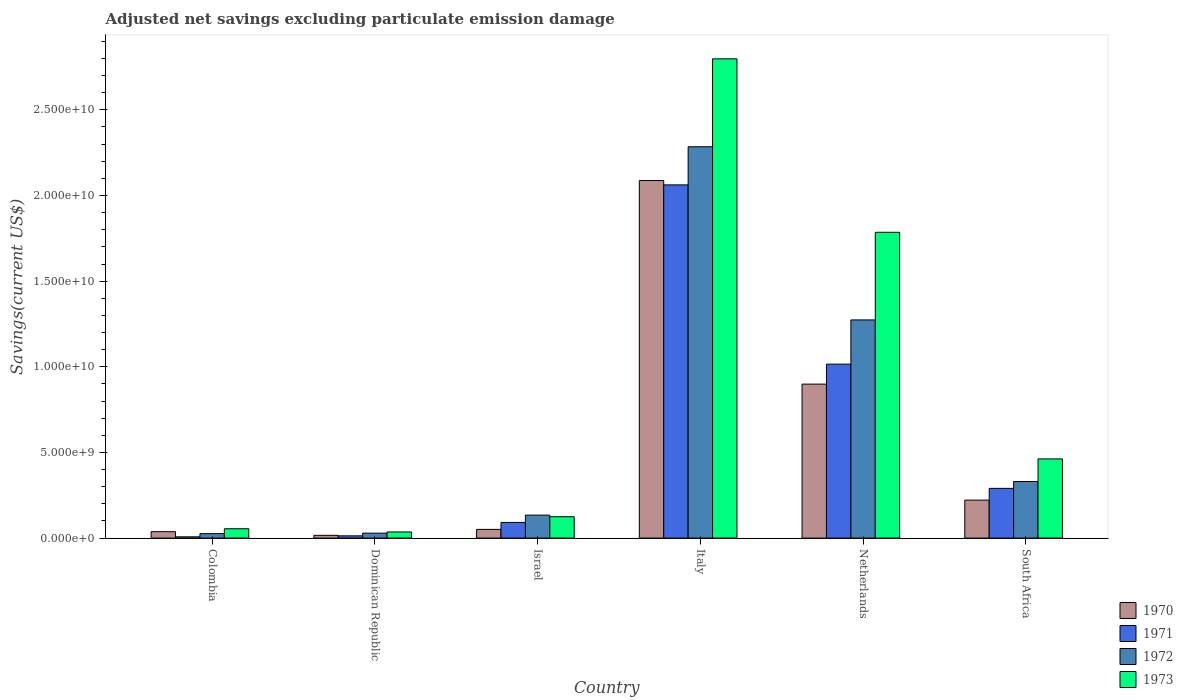How many groups of bars are there?
Keep it short and to the point. 6. Are the number of bars on each tick of the X-axis equal?
Your response must be concise. Yes. What is the label of the 2nd group of bars from the left?
Give a very brief answer. Dominican Republic. What is the adjusted net savings in 1972 in Dominican Republic?
Your answer should be very brief. 2.89e+08. Across all countries, what is the maximum adjusted net savings in 1973?
Offer a very short reply. 2.80e+1. Across all countries, what is the minimum adjusted net savings in 1973?
Give a very brief answer. 3.58e+08. In which country was the adjusted net savings in 1970 maximum?
Your answer should be very brief. Italy. In which country was the adjusted net savings in 1973 minimum?
Ensure brevity in your answer.  Dominican Republic. What is the total adjusted net savings in 1970 in the graph?
Make the answer very short. 3.31e+1. What is the difference between the adjusted net savings in 1973 in Dominican Republic and that in South Africa?
Ensure brevity in your answer.  -4.26e+09. What is the difference between the adjusted net savings in 1971 in Israel and the adjusted net savings in 1970 in Dominican Republic?
Offer a very short reply. 7.53e+08. What is the average adjusted net savings in 1971 per country?
Provide a succinct answer. 5.80e+09. What is the difference between the adjusted net savings of/in 1971 and adjusted net savings of/in 1970 in Dominican Republic?
Make the answer very short. -2.96e+07. What is the ratio of the adjusted net savings in 1971 in Colombia to that in Israel?
Keep it short and to the point. 0.08. Is the adjusted net savings in 1972 in Colombia less than that in Netherlands?
Ensure brevity in your answer.  Yes. What is the difference between the highest and the second highest adjusted net savings in 1970?
Make the answer very short. 1.19e+1. What is the difference between the highest and the lowest adjusted net savings in 1973?
Make the answer very short. 2.76e+1. In how many countries, is the adjusted net savings in 1972 greater than the average adjusted net savings in 1972 taken over all countries?
Offer a terse response. 2. What does the 1st bar from the right in Dominican Republic represents?
Offer a very short reply. 1973. Is it the case that in every country, the sum of the adjusted net savings in 1972 and adjusted net savings in 1973 is greater than the adjusted net savings in 1970?
Offer a very short reply. Yes. How many bars are there?
Keep it short and to the point. 24. How many countries are there in the graph?
Provide a succinct answer. 6. What is the difference between two consecutive major ticks on the Y-axis?
Your answer should be very brief. 5.00e+09. Does the graph contain any zero values?
Offer a terse response. No. Does the graph contain grids?
Give a very brief answer. No. How many legend labels are there?
Offer a very short reply. 4. How are the legend labels stacked?
Provide a succinct answer. Vertical. What is the title of the graph?
Give a very brief answer. Adjusted net savings excluding particulate emission damage. Does "1961" appear as one of the legend labels in the graph?
Your answer should be compact. No. What is the label or title of the X-axis?
Give a very brief answer. Country. What is the label or title of the Y-axis?
Provide a succinct answer. Savings(current US$). What is the Savings(current US$) of 1970 in Colombia?
Keep it short and to the point. 3.74e+08. What is the Savings(current US$) in 1971 in Colombia?
Provide a succinct answer. 7.46e+07. What is the Savings(current US$) of 1972 in Colombia?
Offer a very short reply. 2.60e+08. What is the Savings(current US$) in 1973 in Colombia?
Ensure brevity in your answer.  5.45e+08. What is the Savings(current US$) of 1970 in Dominican Republic?
Give a very brief answer. 1.61e+08. What is the Savings(current US$) in 1971 in Dominican Republic?
Keep it short and to the point. 1.32e+08. What is the Savings(current US$) of 1972 in Dominican Republic?
Make the answer very short. 2.89e+08. What is the Savings(current US$) in 1973 in Dominican Republic?
Your answer should be very brief. 3.58e+08. What is the Savings(current US$) of 1970 in Israel?
Provide a short and direct response. 5.08e+08. What is the Savings(current US$) of 1971 in Israel?
Your answer should be compact. 9.14e+08. What is the Savings(current US$) in 1972 in Israel?
Your answer should be compact. 1.34e+09. What is the Savings(current US$) in 1973 in Israel?
Offer a terse response. 1.25e+09. What is the Savings(current US$) in 1970 in Italy?
Provide a short and direct response. 2.09e+1. What is the Savings(current US$) of 1971 in Italy?
Offer a very short reply. 2.06e+1. What is the Savings(current US$) in 1972 in Italy?
Provide a succinct answer. 2.28e+1. What is the Savings(current US$) in 1973 in Italy?
Your answer should be compact. 2.80e+1. What is the Savings(current US$) in 1970 in Netherlands?
Ensure brevity in your answer.  8.99e+09. What is the Savings(current US$) in 1971 in Netherlands?
Make the answer very short. 1.02e+1. What is the Savings(current US$) in 1972 in Netherlands?
Keep it short and to the point. 1.27e+1. What is the Savings(current US$) of 1973 in Netherlands?
Make the answer very short. 1.79e+1. What is the Savings(current US$) in 1970 in South Africa?
Make the answer very short. 2.22e+09. What is the Savings(current US$) in 1971 in South Africa?
Offer a very short reply. 2.90e+09. What is the Savings(current US$) of 1972 in South Africa?
Ensure brevity in your answer.  3.30e+09. What is the Savings(current US$) of 1973 in South Africa?
Your response must be concise. 4.62e+09. Across all countries, what is the maximum Savings(current US$) of 1970?
Give a very brief answer. 2.09e+1. Across all countries, what is the maximum Savings(current US$) in 1971?
Your answer should be compact. 2.06e+1. Across all countries, what is the maximum Savings(current US$) of 1972?
Your answer should be very brief. 2.28e+1. Across all countries, what is the maximum Savings(current US$) in 1973?
Provide a succinct answer. 2.80e+1. Across all countries, what is the minimum Savings(current US$) in 1970?
Provide a short and direct response. 1.61e+08. Across all countries, what is the minimum Savings(current US$) of 1971?
Your answer should be compact. 7.46e+07. Across all countries, what is the minimum Savings(current US$) in 1972?
Your response must be concise. 2.60e+08. Across all countries, what is the minimum Savings(current US$) in 1973?
Keep it short and to the point. 3.58e+08. What is the total Savings(current US$) of 1970 in the graph?
Your answer should be very brief. 3.31e+1. What is the total Savings(current US$) of 1971 in the graph?
Provide a succinct answer. 3.48e+1. What is the total Savings(current US$) in 1972 in the graph?
Your response must be concise. 4.08e+1. What is the total Savings(current US$) of 1973 in the graph?
Keep it short and to the point. 5.26e+1. What is the difference between the Savings(current US$) of 1970 in Colombia and that in Dominican Republic?
Give a very brief answer. 2.13e+08. What is the difference between the Savings(current US$) in 1971 in Colombia and that in Dominican Republic?
Offer a very short reply. -5.69e+07. What is the difference between the Savings(current US$) of 1972 in Colombia and that in Dominican Republic?
Make the answer very short. -2.84e+07. What is the difference between the Savings(current US$) of 1973 in Colombia and that in Dominican Republic?
Your response must be concise. 1.87e+08. What is the difference between the Savings(current US$) of 1970 in Colombia and that in Israel?
Your answer should be compact. -1.34e+08. What is the difference between the Savings(current US$) in 1971 in Colombia and that in Israel?
Give a very brief answer. -8.40e+08. What is the difference between the Savings(current US$) in 1972 in Colombia and that in Israel?
Your answer should be compact. -1.08e+09. What is the difference between the Savings(current US$) in 1973 in Colombia and that in Israel?
Make the answer very short. -7.02e+08. What is the difference between the Savings(current US$) of 1970 in Colombia and that in Italy?
Provide a succinct answer. -2.05e+1. What is the difference between the Savings(current US$) in 1971 in Colombia and that in Italy?
Offer a very short reply. -2.05e+1. What is the difference between the Savings(current US$) of 1972 in Colombia and that in Italy?
Provide a short and direct response. -2.26e+1. What is the difference between the Savings(current US$) of 1973 in Colombia and that in Italy?
Offer a very short reply. -2.74e+1. What is the difference between the Savings(current US$) of 1970 in Colombia and that in Netherlands?
Provide a succinct answer. -8.61e+09. What is the difference between the Savings(current US$) of 1971 in Colombia and that in Netherlands?
Ensure brevity in your answer.  -1.01e+1. What is the difference between the Savings(current US$) in 1972 in Colombia and that in Netherlands?
Provide a succinct answer. -1.25e+1. What is the difference between the Savings(current US$) in 1973 in Colombia and that in Netherlands?
Ensure brevity in your answer.  -1.73e+1. What is the difference between the Savings(current US$) of 1970 in Colombia and that in South Africa?
Keep it short and to the point. -1.84e+09. What is the difference between the Savings(current US$) in 1971 in Colombia and that in South Africa?
Provide a succinct answer. -2.83e+09. What is the difference between the Savings(current US$) in 1972 in Colombia and that in South Africa?
Ensure brevity in your answer.  -3.04e+09. What is the difference between the Savings(current US$) in 1973 in Colombia and that in South Africa?
Your answer should be very brief. -4.08e+09. What is the difference between the Savings(current US$) of 1970 in Dominican Republic and that in Israel?
Make the answer very short. -3.47e+08. What is the difference between the Savings(current US$) of 1971 in Dominican Republic and that in Israel?
Offer a very short reply. -7.83e+08. What is the difference between the Savings(current US$) of 1972 in Dominican Republic and that in Israel?
Ensure brevity in your answer.  -1.05e+09. What is the difference between the Savings(current US$) in 1973 in Dominican Republic and that in Israel?
Offer a terse response. -8.89e+08. What is the difference between the Savings(current US$) of 1970 in Dominican Republic and that in Italy?
Keep it short and to the point. -2.07e+1. What is the difference between the Savings(current US$) in 1971 in Dominican Republic and that in Italy?
Your answer should be compact. -2.05e+1. What is the difference between the Savings(current US$) in 1972 in Dominican Republic and that in Italy?
Ensure brevity in your answer.  -2.26e+1. What is the difference between the Savings(current US$) in 1973 in Dominican Republic and that in Italy?
Your answer should be compact. -2.76e+1. What is the difference between the Savings(current US$) in 1970 in Dominican Republic and that in Netherlands?
Offer a terse response. -8.83e+09. What is the difference between the Savings(current US$) in 1971 in Dominican Republic and that in Netherlands?
Provide a short and direct response. -1.00e+1. What is the difference between the Savings(current US$) in 1972 in Dominican Republic and that in Netherlands?
Your answer should be very brief. -1.24e+1. What is the difference between the Savings(current US$) of 1973 in Dominican Republic and that in Netherlands?
Provide a succinct answer. -1.75e+1. What is the difference between the Savings(current US$) of 1970 in Dominican Republic and that in South Africa?
Offer a terse response. -2.06e+09. What is the difference between the Savings(current US$) of 1971 in Dominican Republic and that in South Africa?
Make the answer very short. -2.77e+09. What is the difference between the Savings(current US$) in 1972 in Dominican Republic and that in South Africa?
Your response must be concise. -3.01e+09. What is the difference between the Savings(current US$) in 1973 in Dominican Republic and that in South Africa?
Provide a succinct answer. -4.26e+09. What is the difference between the Savings(current US$) in 1970 in Israel and that in Italy?
Ensure brevity in your answer.  -2.04e+1. What is the difference between the Savings(current US$) of 1971 in Israel and that in Italy?
Make the answer very short. -1.97e+1. What is the difference between the Savings(current US$) of 1972 in Israel and that in Italy?
Your response must be concise. -2.15e+1. What is the difference between the Savings(current US$) of 1973 in Israel and that in Italy?
Your answer should be very brief. -2.67e+1. What is the difference between the Savings(current US$) in 1970 in Israel and that in Netherlands?
Provide a succinct answer. -8.48e+09. What is the difference between the Savings(current US$) of 1971 in Israel and that in Netherlands?
Provide a succinct answer. -9.24e+09. What is the difference between the Savings(current US$) of 1972 in Israel and that in Netherlands?
Your answer should be very brief. -1.14e+1. What is the difference between the Savings(current US$) in 1973 in Israel and that in Netherlands?
Offer a very short reply. -1.66e+1. What is the difference between the Savings(current US$) in 1970 in Israel and that in South Africa?
Ensure brevity in your answer.  -1.71e+09. What is the difference between the Savings(current US$) in 1971 in Israel and that in South Africa?
Ensure brevity in your answer.  -1.99e+09. What is the difference between the Savings(current US$) of 1972 in Israel and that in South Africa?
Your response must be concise. -1.96e+09. What is the difference between the Savings(current US$) in 1973 in Israel and that in South Africa?
Make the answer very short. -3.38e+09. What is the difference between the Savings(current US$) in 1970 in Italy and that in Netherlands?
Make the answer very short. 1.19e+1. What is the difference between the Savings(current US$) of 1971 in Italy and that in Netherlands?
Provide a short and direct response. 1.05e+1. What is the difference between the Savings(current US$) in 1972 in Italy and that in Netherlands?
Keep it short and to the point. 1.01e+1. What is the difference between the Savings(current US$) of 1973 in Italy and that in Netherlands?
Offer a very short reply. 1.01e+1. What is the difference between the Savings(current US$) in 1970 in Italy and that in South Africa?
Offer a very short reply. 1.87e+1. What is the difference between the Savings(current US$) in 1971 in Italy and that in South Africa?
Your answer should be very brief. 1.77e+1. What is the difference between the Savings(current US$) of 1972 in Italy and that in South Africa?
Keep it short and to the point. 1.95e+1. What is the difference between the Savings(current US$) of 1973 in Italy and that in South Africa?
Keep it short and to the point. 2.34e+1. What is the difference between the Savings(current US$) of 1970 in Netherlands and that in South Africa?
Give a very brief answer. 6.77e+09. What is the difference between the Savings(current US$) of 1971 in Netherlands and that in South Africa?
Provide a short and direct response. 7.25e+09. What is the difference between the Savings(current US$) of 1972 in Netherlands and that in South Africa?
Make the answer very short. 9.43e+09. What is the difference between the Savings(current US$) of 1973 in Netherlands and that in South Africa?
Provide a succinct answer. 1.32e+1. What is the difference between the Savings(current US$) in 1970 in Colombia and the Savings(current US$) in 1971 in Dominican Republic?
Provide a short and direct response. 2.42e+08. What is the difference between the Savings(current US$) in 1970 in Colombia and the Savings(current US$) in 1972 in Dominican Republic?
Give a very brief answer. 8.52e+07. What is the difference between the Savings(current US$) of 1970 in Colombia and the Savings(current US$) of 1973 in Dominican Republic?
Keep it short and to the point. 1.57e+07. What is the difference between the Savings(current US$) of 1971 in Colombia and the Savings(current US$) of 1972 in Dominican Republic?
Provide a succinct answer. -2.14e+08. What is the difference between the Savings(current US$) in 1971 in Colombia and the Savings(current US$) in 1973 in Dominican Republic?
Your response must be concise. -2.84e+08. What is the difference between the Savings(current US$) in 1972 in Colombia and the Savings(current US$) in 1973 in Dominican Republic?
Provide a succinct answer. -9.79e+07. What is the difference between the Savings(current US$) in 1970 in Colombia and the Savings(current US$) in 1971 in Israel?
Provide a short and direct response. -5.40e+08. What is the difference between the Savings(current US$) of 1970 in Colombia and the Savings(current US$) of 1972 in Israel?
Ensure brevity in your answer.  -9.67e+08. What is the difference between the Savings(current US$) of 1970 in Colombia and the Savings(current US$) of 1973 in Israel?
Your response must be concise. -8.73e+08. What is the difference between the Savings(current US$) in 1971 in Colombia and the Savings(current US$) in 1972 in Israel?
Provide a succinct answer. -1.27e+09. What is the difference between the Savings(current US$) in 1971 in Colombia and the Savings(current US$) in 1973 in Israel?
Provide a succinct answer. -1.17e+09. What is the difference between the Savings(current US$) of 1972 in Colombia and the Savings(current US$) of 1973 in Israel?
Your answer should be compact. -9.87e+08. What is the difference between the Savings(current US$) in 1970 in Colombia and the Savings(current US$) in 1971 in Italy?
Provide a succinct answer. -2.02e+1. What is the difference between the Savings(current US$) of 1970 in Colombia and the Savings(current US$) of 1972 in Italy?
Offer a terse response. -2.25e+1. What is the difference between the Savings(current US$) of 1970 in Colombia and the Savings(current US$) of 1973 in Italy?
Your response must be concise. -2.76e+1. What is the difference between the Savings(current US$) in 1971 in Colombia and the Savings(current US$) in 1972 in Italy?
Make the answer very short. -2.28e+1. What is the difference between the Savings(current US$) of 1971 in Colombia and the Savings(current US$) of 1973 in Italy?
Give a very brief answer. -2.79e+1. What is the difference between the Savings(current US$) in 1972 in Colombia and the Savings(current US$) in 1973 in Italy?
Your answer should be very brief. -2.77e+1. What is the difference between the Savings(current US$) of 1970 in Colombia and the Savings(current US$) of 1971 in Netherlands?
Keep it short and to the point. -9.78e+09. What is the difference between the Savings(current US$) of 1970 in Colombia and the Savings(current US$) of 1972 in Netherlands?
Give a very brief answer. -1.24e+1. What is the difference between the Savings(current US$) of 1970 in Colombia and the Savings(current US$) of 1973 in Netherlands?
Your answer should be compact. -1.75e+1. What is the difference between the Savings(current US$) of 1971 in Colombia and the Savings(current US$) of 1972 in Netherlands?
Your response must be concise. -1.27e+1. What is the difference between the Savings(current US$) in 1971 in Colombia and the Savings(current US$) in 1973 in Netherlands?
Ensure brevity in your answer.  -1.78e+1. What is the difference between the Savings(current US$) of 1972 in Colombia and the Savings(current US$) of 1973 in Netherlands?
Make the answer very short. -1.76e+1. What is the difference between the Savings(current US$) in 1970 in Colombia and the Savings(current US$) in 1971 in South Africa?
Give a very brief answer. -2.53e+09. What is the difference between the Savings(current US$) of 1970 in Colombia and the Savings(current US$) of 1972 in South Africa?
Give a very brief answer. -2.93e+09. What is the difference between the Savings(current US$) in 1970 in Colombia and the Savings(current US$) in 1973 in South Africa?
Keep it short and to the point. -4.25e+09. What is the difference between the Savings(current US$) in 1971 in Colombia and the Savings(current US$) in 1972 in South Africa?
Provide a succinct answer. -3.23e+09. What is the difference between the Savings(current US$) of 1971 in Colombia and the Savings(current US$) of 1973 in South Africa?
Provide a short and direct response. -4.55e+09. What is the difference between the Savings(current US$) in 1972 in Colombia and the Savings(current US$) in 1973 in South Africa?
Give a very brief answer. -4.36e+09. What is the difference between the Savings(current US$) in 1970 in Dominican Republic and the Savings(current US$) in 1971 in Israel?
Offer a very short reply. -7.53e+08. What is the difference between the Savings(current US$) in 1970 in Dominican Republic and the Savings(current US$) in 1972 in Israel?
Provide a succinct answer. -1.18e+09. What is the difference between the Savings(current US$) in 1970 in Dominican Republic and the Savings(current US$) in 1973 in Israel?
Give a very brief answer. -1.09e+09. What is the difference between the Savings(current US$) of 1971 in Dominican Republic and the Savings(current US$) of 1972 in Israel?
Make the answer very short. -1.21e+09. What is the difference between the Savings(current US$) of 1971 in Dominican Republic and the Savings(current US$) of 1973 in Israel?
Offer a terse response. -1.12e+09. What is the difference between the Savings(current US$) in 1972 in Dominican Republic and the Savings(current US$) in 1973 in Israel?
Provide a short and direct response. -9.58e+08. What is the difference between the Savings(current US$) of 1970 in Dominican Republic and the Savings(current US$) of 1971 in Italy?
Ensure brevity in your answer.  -2.05e+1. What is the difference between the Savings(current US$) in 1970 in Dominican Republic and the Savings(current US$) in 1972 in Italy?
Your answer should be compact. -2.27e+1. What is the difference between the Savings(current US$) of 1970 in Dominican Republic and the Savings(current US$) of 1973 in Italy?
Provide a succinct answer. -2.78e+1. What is the difference between the Savings(current US$) in 1971 in Dominican Republic and the Savings(current US$) in 1972 in Italy?
Ensure brevity in your answer.  -2.27e+1. What is the difference between the Savings(current US$) in 1971 in Dominican Republic and the Savings(current US$) in 1973 in Italy?
Provide a succinct answer. -2.78e+1. What is the difference between the Savings(current US$) in 1972 in Dominican Republic and the Savings(current US$) in 1973 in Italy?
Ensure brevity in your answer.  -2.77e+1. What is the difference between the Savings(current US$) in 1970 in Dominican Republic and the Savings(current US$) in 1971 in Netherlands?
Offer a very short reply. -9.99e+09. What is the difference between the Savings(current US$) in 1970 in Dominican Republic and the Savings(current US$) in 1972 in Netherlands?
Your response must be concise. -1.26e+1. What is the difference between the Savings(current US$) of 1970 in Dominican Republic and the Savings(current US$) of 1973 in Netherlands?
Your answer should be compact. -1.77e+1. What is the difference between the Savings(current US$) in 1971 in Dominican Republic and the Savings(current US$) in 1972 in Netherlands?
Offer a terse response. -1.26e+1. What is the difference between the Savings(current US$) of 1971 in Dominican Republic and the Savings(current US$) of 1973 in Netherlands?
Provide a short and direct response. -1.77e+1. What is the difference between the Savings(current US$) of 1972 in Dominican Republic and the Savings(current US$) of 1973 in Netherlands?
Your response must be concise. -1.76e+1. What is the difference between the Savings(current US$) in 1970 in Dominican Republic and the Savings(current US$) in 1971 in South Africa?
Ensure brevity in your answer.  -2.74e+09. What is the difference between the Savings(current US$) in 1970 in Dominican Republic and the Savings(current US$) in 1972 in South Africa?
Your answer should be very brief. -3.14e+09. What is the difference between the Savings(current US$) in 1970 in Dominican Republic and the Savings(current US$) in 1973 in South Africa?
Your answer should be compact. -4.46e+09. What is the difference between the Savings(current US$) in 1971 in Dominican Republic and the Savings(current US$) in 1972 in South Africa?
Keep it short and to the point. -3.17e+09. What is the difference between the Savings(current US$) of 1971 in Dominican Republic and the Savings(current US$) of 1973 in South Africa?
Keep it short and to the point. -4.49e+09. What is the difference between the Savings(current US$) of 1972 in Dominican Republic and the Savings(current US$) of 1973 in South Africa?
Provide a succinct answer. -4.33e+09. What is the difference between the Savings(current US$) in 1970 in Israel and the Savings(current US$) in 1971 in Italy?
Offer a terse response. -2.01e+1. What is the difference between the Savings(current US$) of 1970 in Israel and the Savings(current US$) of 1972 in Italy?
Your response must be concise. -2.23e+1. What is the difference between the Savings(current US$) in 1970 in Israel and the Savings(current US$) in 1973 in Italy?
Make the answer very short. -2.75e+1. What is the difference between the Savings(current US$) of 1971 in Israel and the Savings(current US$) of 1972 in Italy?
Your answer should be compact. -2.19e+1. What is the difference between the Savings(current US$) in 1971 in Israel and the Savings(current US$) in 1973 in Italy?
Ensure brevity in your answer.  -2.71e+1. What is the difference between the Savings(current US$) of 1972 in Israel and the Savings(current US$) of 1973 in Italy?
Provide a succinct answer. -2.66e+1. What is the difference between the Savings(current US$) in 1970 in Israel and the Savings(current US$) in 1971 in Netherlands?
Provide a short and direct response. -9.65e+09. What is the difference between the Savings(current US$) of 1970 in Israel and the Savings(current US$) of 1972 in Netherlands?
Keep it short and to the point. -1.22e+1. What is the difference between the Savings(current US$) in 1970 in Israel and the Savings(current US$) in 1973 in Netherlands?
Give a very brief answer. -1.73e+1. What is the difference between the Savings(current US$) of 1971 in Israel and the Savings(current US$) of 1972 in Netherlands?
Ensure brevity in your answer.  -1.18e+1. What is the difference between the Savings(current US$) in 1971 in Israel and the Savings(current US$) in 1973 in Netherlands?
Provide a succinct answer. -1.69e+1. What is the difference between the Savings(current US$) of 1972 in Israel and the Savings(current US$) of 1973 in Netherlands?
Keep it short and to the point. -1.65e+1. What is the difference between the Savings(current US$) of 1970 in Israel and the Savings(current US$) of 1971 in South Africa?
Give a very brief answer. -2.39e+09. What is the difference between the Savings(current US$) in 1970 in Israel and the Savings(current US$) in 1972 in South Africa?
Your response must be concise. -2.79e+09. What is the difference between the Savings(current US$) of 1970 in Israel and the Savings(current US$) of 1973 in South Africa?
Ensure brevity in your answer.  -4.11e+09. What is the difference between the Savings(current US$) in 1971 in Israel and the Savings(current US$) in 1972 in South Africa?
Give a very brief answer. -2.39e+09. What is the difference between the Savings(current US$) of 1971 in Israel and the Savings(current US$) of 1973 in South Africa?
Your response must be concise. -3.71e+09. What is the difference between the Savings(current US$) of 1972 in Israel and the Savings(current US$) of 1973 in South Africa?
Your response must be concise. -3.28e+09. What is the difference between the Savings(current US$) in 1970 in Italy and the Savings(current US$) in 1971 in Netherlands?
Offer a very short reply. 1.07e+1. What is the difference between the Savings(current US$) of 1970 in Italy and the Savings(current US$) of 1972 in Netherlands?
Ensure brevity in your answer.  8.14e+09. What is the difference between the Savings(current US$) of 1970 in Italy and the Savings(current US$) of 1973 in Netherlands?
Make the answer very short. 3.02e+09. What is the difference between the Savings(current US$) of 1971 in Italy and the Savings(current US$) of 1972 in Netherlands?
Provide a short and direct response. 7.88e+09. What is the difference between the Savings(current US$) of 1971 in Italy and the Savings(current US$) of 1973 in Netherlands?
Keep it short and to the point. 2.77e+09. What is the difference between the Savings(current US$) of 1972 in Italy and the Savings(current US$) of 1973 in Netherlands?
Provide a short and direct response. 4.99e+09. What is the difference between the Savings(current US$) in 1970 in Italy and the Savings(current US$) in 1971 in South Africa?
Your answer should be compact. 1.80e+1. What is the difference between the Savings(current US$) of 1970 in Italy and the Savings(current US$) of 1972 in South Africa?
Offer a terse response. 1.76e+1. What is the difference between the Savings(current US$) in 1970 in Italy and the Savings(current US$) in 1973 in South Africa?
Your answer should be compact. 1.62e+1. What is the difference between the Savings(current US$) of 1971 in Italy and the Savings(current US$) of 1972 in South Africa?
Offer a terse response. 1.73e+1. What is the difference between the Savings(current US$) of 1971 in Italy and the Savings(current US$) of 1973 in South Africa?
Offer a very short reply. 1.60e+1. What is the difference between the Savings(current US$) of 1972 in Italy and the Savings(current US$) of 1973 in South Africa?
Your answer should be very brief. 1.82e+1. What is the difference between the Savings(current US$) of 1970 in Netherlands and the Savings(current US$) of 1971 in South Africa?
Make the answer very short. 6.09e+09. What is the difference between the Savings(current US$) in 1970 in Netherlands and the Savings(current US$) in 1972 in South Africa?
Your answer should be very brief. 5.69e+09. What is the difference between the Savings(current US$) of 1970 in Netherlands and the Savings(current US$) of 1973 in South Africa?
Give a very brief answer. 4.37e+09. What is the difference between the Savings(current US$) of 1971 in Netherlands and the Savings(current US$) of 1972 in South Africa?
Make the answer very short. 6.85e+09. What is the difference between the Savings(current US$) of 1971 in Netherlands and the Savings(current US$) of 1973 in South Africa?
Keep it short and to the point. 5.53e+09. What is the difference between the Savings(current US$) of 1972 in Netherlands and the Savings(current US$) of 1973 in South Africa?
Offer a very short reply. 8.11e+09. What is the average Savings(current US$) of 1970 per country?
Give a very brief answer. 5.52e+09. What is the average Savings(current US$) in 1971 per country?
Offer a terse response. 5.80e+09. What is the average Savings(current US$) in 1972 per country?
Give a very brief answer. 6.80e+09. What is the average Savings(current US$) in 1973 per country?
Provide a succinct answer. 8.77e+09. What is the difference between the Savings(current US$) in 1970 and Savings(current US$) in 1971 in Colombia?
Ensure brevity in your answer.  2.99e+08. What is the difference between the Savings(current US$) in 1970 and Savings(current US$) in 1972 in Colombia?
Give a very brief answer. 1.14e+08. What is the difference between the Savings(current US$) of 1970 and Savings(current US$) of 1973 in Colombia?
Your answer should be very brief. -1.71e+08. What is the difference between the Savings(current US$) of 1971 and Savings(current US$) of 1972 in Colombia?
Your answer should be compact. -1.86e+08. What is the difference between the Savings(current US$) of 1971 and Savings(current US$) of 1973 in Colombia?
Your response must be concise. -4.70e+08. What is the difference between the Savings(current US$) in 1972 and Savings(current US$) in 1973 in Colombia?
Your answer should be very brief. -2.85e+08. What is the difference between the Savings(current US$) of 1970 and Savings(current US$) of 1971 in Dominican Republic?
Keep it short and to the point. 2.96e+07. What is the difference between the Savings(current US$) in 1970 and Savings(current US$) in 1972 in Dominican Republic?
Offer a very short reply. -1.28e+08. What is the difference between the Savings(current US$) of 1970 and Savings(current US$) of 1973 in Dominican Republic?
Make the answer very short. -1.97e+08. What is the difference between the Savings(current US$) in 1971 and Savings(current US$) in 1972 in Dominican Republic?
Your answer should be very brief. -1.57e+08. What is the difference between the Savings(current US$) in 1971 and Savings(current US$) in 1973 in Dominican Republic?
Provide a short and direct response. -2.27e+08. What is the difference between the Savings(current US$) of 1972 and Savings(current US$) of 1973 in Dominican Republic?
Provide a succinct answer. -6.95e+07. What is the difference between the Savings(current US$) in 1970 and Savings(current US$) in 1971 in Israel?
Offer a very short reply. -4.06e+08. What is the difference between the Savings(current US$) of 1970 and Savings(current US$) of 1972 in Israel?
Provide a succinct answer. -8.33e+08. What is the difference between the Savings(current US$) of 1970 and Savings(current US$) of 1973 in Israel?
Offer a terse response. -7.39e+08. What is the difference between the Savings(current US$) in 1971 and Savings(current US$) in 1972 in Israel?
Provide a succinct answer. -4.27e+08. What is the difference between the Savings(current US$) in 1971 and Savings(current US$) in 1973 in Israel?
Keep it short and to the point. -3.33e+08. What is the difference between the Savings(current US$) of 1972 and Savings(current US$) of 1973 in Israel?
Keep it short and to the point. 9.40e+07. What is the difference between the Savings(current US$) in 1970 and Savings(current US$) in 1971 in Italy?
Give a very brief answer. 2.53e+08. What is the difference between the Savings(current US$) of 1970 and Savings(current US$) of 1972 in Italy?
Offer a terse response. -1.97e+09. What is the difference between the Savings(current US$) in 1970 and Savings(current US$) in 1973 in Italy?
Offer a terse response. -7.11e+09. What is the difference between the Savings(current US$) in 1971 and Savings(current US$) in 1972 in Italy?
Provide a short and direct response. -2.23e+09. What is the difference between the Savings(current US$) of 1971 and Savings(current US$) of 1973 in Italy?
Your answer should be very brief. -7.36e+09. What is the difference between the Savings(current US$) in 1972 and Savings(current US$) in 1973 in Italy?
Provide a short and direct response. -5.13e+09. What is the difference between the Savings(current US$) in 1970 and Savings(current US$) in 1971 in Netherlands?
Provide a succinct answer. -1.17e+09. What is the difference between the Savings(current US$) of 1970 and Savings(current US$) of 1972 in Netherlands?
Offer a very short reply. -3.75e+09. What is the difference between the Savings(current US$) of 1970 and Savings(current US$) of 1973 in Netherlands?
Provide a succinct answer. -8.86e+09. What is the difference between the Savings(current US$) in 1971 and Savings(current US$) in 1972 in Netherlands?
Your answer should be very brief. -2.58e+09. What is the difference between the Savings(current US$) of 1971 and Savings(current US$) of 1973 in Netherlands?
Your answer should be very brief. -7.70e+09. What is the difference between the Savings(current US$) of 1972 and Savings(current US$) of 1973 in Netherlands?
Offer a terse response. -5.11e+09. What is the difference between the Savings(current US$) of 1970 and Savings(current US$) of 1971 in South Africa?
Offer a terse response. -6.85e+08. What is the difference between the Savings(current US$) in 1970 and Savings(current US$) in 1972 in South Africa?
Give a very brief answer. -1.08e+09. What is the difference between the Savings(current US$) of 1970 and Savings(current US$) of 1973 in South Africa?
Your response must be concise. -2.40e+09. What is the difference between the Savings(current US$) in 1971 and Savings(current US$) in 1972 in South Africa?
Your response must be concise. -4.00e+08. What is the difference between the Savings(current US$) in 1971 and Savings(current US$) in 1973 in South Africa?
Make the answer very short. -1.72e+09. What is the difference between the Savings(current US$) in 1972 and Savings(current US$) in 1973 in South Africa?
Your response must be concise. -1.32e+09. What is the ratio of the Savings(current US$) of 1970 in Colombia to that in Dominican Republic?
Offer a terse response. 2.32. What is the ratio of the Savings(current US$) of 1971 in Colombia to that in Dominican Republic?
Ensure brevity in your answer.  0.57. What is the ratio of the Savings(current US$) of 1972 in Colombia to that in Dominican Republic?
Make the answer very short. 0.9. What is the ratio of the Savings(current US$) in 1973 in Colombia to that in Dominican Republic?
Your answer should be compact. 1.52. What is the ratio of the Savings(current US$) in 1970 in Colombia to that in Israel?
Provide a short and direct response. 0.74. What is the ratio of the Savings(current US$) in 1971 in Colombia to that in Israel?
Your answer should be very brief. 0.08. What is the ratio of the Savings(current US$) in 1972 in Colombia to that in Israel?
Give a very brief answer. 0.19. What is the ratio of the Savings(current US$) of 1973 in Colombia to that in Israel?
Ensure brevity in your answer.  0.44. What is the ratio of the Savings(current US$) in 1970 in Colombia to that in Italy?
Your answer should be compact. 0.02. What is the ratio of the Savings(current US$) of 1971 in Colombia to that in Italy?
Give a very brief answer. 0. What is the ratio of the Savings(current US$) of 1972 in Colombia to that in Italy?
Your response must be concise. 0.01. What is the ratio of the Savings(current US$) in 1973 in Colombia to that in Italy?
Offer a very short reply. 0.02. What is the ratio of the Savings(current US$) in 1970 in Colombia to that in Netherlands?
Provide a short and direct response. 0.04. What is the ratio of the Savings(current US$) of 1971 in Colombia to that in Netherlands?
Your answer should be very brief. 0.01. What is the ratio of the Savings(current US$) in 1972 in Colombia to that in Netherlands?
Ensure brevity in your answer.  0.02. What is the ratio of the Savings(current US$) in 1973 in Colombia to that in Netherlands?
Make the answer very short. 0.03. What is the ratio of the Savings(current US$) of 1970 in Colombia to that in South Africa?
Your answer should be very brief. 0.17. What is the ratio of the Savings(current US$) of 1971 in Colombia to that in South Africa?
Ensure brevity in your answer.  0.03. What is the ratio of the Savings(current US$) of 1972 in Colombia to that in South Africa?
Provide a short and direct response. 0.08. What is the ratio of the Savings(current US$) in 1973 in Colombia to that in South Africa?
Your answer should be compact. 0.12. What is the ratio of the Savings(current US$) of 1970 in Dominican Republic to that in Israel?
Your answer should be very brief. 0.32. What is the ratio of the Savings(current US$) in 1971 in Dominican Republic to that in Israel?
Your response must be concise. 0.14. What is the ratio of the Savings(current US$) in 1972 in Dominican Republic to that in Israel?
Give a very brief answer. 0.22. What is the ratio of the Savings(current US$) in 1973 in Dominican Republic to that in Israel?
Provide a succinct answer. 0.29. What is the ratio of the Savings(current US$) of 1970 in Dominican Republic to that in Italy?
Make the answer very short. 0.01. What is the ratio of the Savings(current US$) of 1971 in Dominican Republic to that in Italy?
Provide a short and direct response. 0.01. What is the ratio of the Savings(current US$) of 1972 in Dominican Republic to that in Italy?
Give a very brief answer. 0.01. What is the ratio of the Savings(current US$) in 1973 in Dominican Republic to that in Italy?
Provide a succinct answer. 0.01. What is the ratio of the Savings(current US$) of 1970 in Dominican Republic to that in Netherlands?
Make the answer very short. 0.02. What is the ratio of the Savings(current US$) in 1971 in Dominican Republic to that in Netherlands?
Keep it short and to the point. 0.01. What is the ratio of the Savings(current US$) in 1972 in Dominican Republic to that in Netherlands?
Keep it short and to the point. 0.02. What is the ratio of the Savings(current US$) of 1973 in Dominican Republic to that in Netherlands?
Provide a succinct answer. 0.02. What is the ratio of the Savings(current US$) in 1970 in Dominican Republic to that in South Africa?
Provide a short and direct response. 0.07. What is the ratio of the Savings(current US$) of 1971 in Dominican Republic to that in South Africa?
Your response must be concise. 0.05. What is the ratio of the Savings(current US$) in 1972 in Dominican Republic to that in South Africa?
Give a very brief answer. 0.09. What is the ratio of the Savings(current US$) of 1973 in Dominican Republic to that in South Africa?
Your response must be concise. 0.08. What is the ratio of the Savings(current US$) in 1970 in Israel to that in Italy?
Keep it short and to the point. 0.02. What is the ratio of the Savings(current US$) in 1971 in Israel to that in Italy?
Offer a very short reply. 0.04. What is the ratio of the Savings(current US$) of 1972 in Israel to that in Italy?
Make the answer very short. 0.06. What is the ratio of the Savings(current US$) of 1973 in Israel to that in Italy?
Your answer should be very brief. 0.04. What is the ratio of the Savings(current US$) of 1970 in Israel to that in Netherlands?
Make the answer very short. 0.06. What is the ratio of the Savings(current US$) in 1971 in Israel to that in Netherlands?
Ensure brevity in your answer.  0.09. What is the ratio of the Savings(current US$) of 1972 in Israel to that in Netherlands?
Your answer should be compact. 0.11. What is the ratio of the Savings(current US$) in 1973 in Israel to that in Netherlands?
Ensure brevity in your answer.  0.07. What is the ratio of the Savings(current US$) of 1970 in Israel to that in South Africa?
Give a very brief answer. 0.23. What is the ratio of the Savings(current US$) of 1971 in Israel to that in South Africa?
Your answer should be very brief. 0.32. What is the ratio of the Savings(current US$) in 1972 in Israel to that in South Africa?
Give a very brief answer. 0.41. What is the ratio of the Savings(current US$) of 1973 in Israel to that in South Africa?
Offer a very short reply. 0.27. What is the ratio of the Savings(current US$) in 1970 in Italy to that in Netherlands?
Make the answer very short. 2.32. What is the ratio of the Savings(current US$) of 1971 in Italy to that in Netherlands?
Give a very brief answer. 2.03. What is the ratio of the Savings(current US$) in 1972 in Italy to that in Netherlands?
Your response must be concise. 1.79. What is the ratio of the Savings(current US$) in 1973 in Italy to that in Netherlands?
Make the answer very short. 1.57. What is the ratio of the Savings(current US$) of 1970 in Italy to that in South Africa?
Offer a very short reply. 9.41. What is the ratio of the Savings(current US$) in 1971 in Italy to that in South Africa?
Your answer should be compact. 7.1. What is the ratio of the Savings(current US$) of 1972 in Italy to that in South Africa?
Offer a terse response. 6.92. What is the ratio of the Savings(current US$) of 1973 in Italy to that in South Africa?
Your answer should be very brief. 6.05. What is the ratio of the Savings(current US$) in 1970 in Netherlands to that in South Africa?
Offer a very short reply. 4.05. What is the ratio of the Savings(current US$) in 1971 in Netherlands to that in South Africa?
Offer a terse response. 3.5. What is the ratio of the Savings(current US$) in 1972 in Netherlands to that in South Africa?
Your answer should be very brief. 3.86. What is the ratio of the Savings(current US$) in 1973 in Netherlands to that in South Africa?
Offer a very short reply. 3.86. What is the difference between the highest and the second highest Savings(current US$) of 1970?
Your response must be concise. 1.19e+1. What is the difference between the highest and the second highest Savings(current US$) of 1971?
Keep it short and to the point. 1.05e+1. What is the difference between the highest and the second highest Savings(current US$) of 1972?
Provide a succinct answer. 1.01e+1. What is the difference between the highest and the second highest Savings(current US$) of 1973?
Offer a very short reply. 1.01e+1. What is the difference between the highest and the lowest Savings(current US$) in 1970?
Give a very brief answer. 2.07e+1. What is the difference between the highest and the lowest Savings(current US$) of 1971?
Offer a terse response. 2.05e+1. What is the difference between the highest and the lowest Savings(current US$) in 1972?
Your answer should be compact. 2.26e+1. What is the difference between the highest and the lowest Savings(current US$) in 1973?
Your answer should be compact. 2.76e+1. 